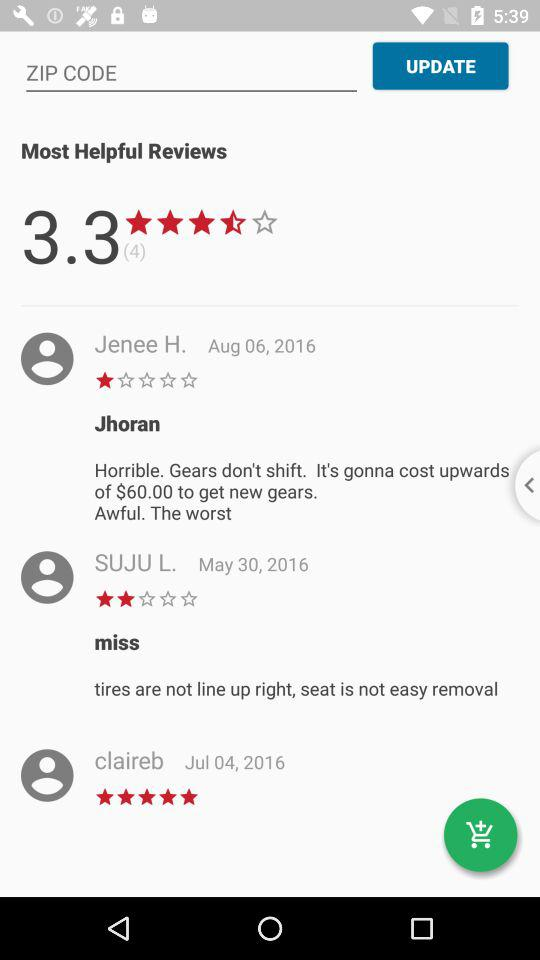How many reviews in total are there? There are 3.3 reviews in total. 